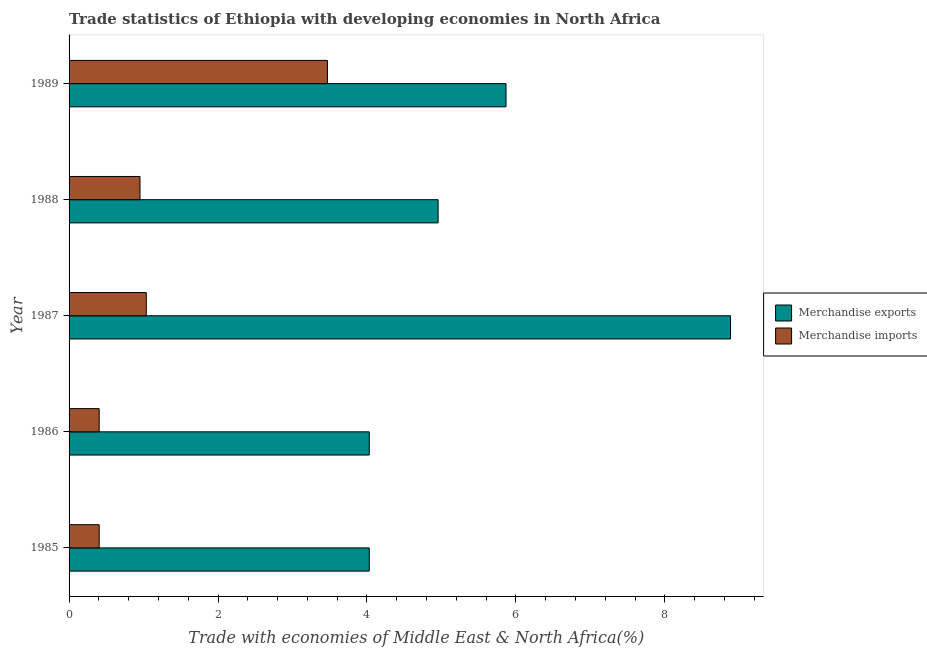How many different coloured bars are there?
Your response must be concise. 2. How many groups of bars are there?
Offer a very short reply. 5. Are the number of bars on each tick of the Y-axis equal?
Give a very brief answer. Yes. What is the label of the 5th group of bars from the top?
Your response must be concise. 1985. In how many cases, is the number of bars for a given year not equal to the number of legend labels?
Ensure brevity in your answer.  0. What is the merchandise exports in 1989?
Provide a succinct answer. 5.87. Across all years, what is the maximum merchandise imports?
Offer a terse response. 3.47. Across all years, what is the minimum merchandise exports?
Keep it short and to the point. 4.03. In which year was the merchandise imports maximum?
Your answer should be compact. 1989. What is the total merchandise imports in the graph?
Your answer should be compact. 6.27. What is the difference between the merchandise exports in 1985 and that in 1986?
Make the answer very short. -0. What is the difference between the merchandise imports in 1987 and the merchandise exports in 1988?
Your answer should be very brief. -3.92. What is the average merchandise imports per year?
Provide a short and direct response. 1.25. In the year 1985, what is the difference between the merchandise exports and merchandise imports?
Give a very brief answer. 3.63. What is the ratio of the merchandise imports in 1986 to that in 1988?
Ensure brevity in your answer.  0.42. Is the merchandise imports in 1986 less than that in 1987?
Give a very brief answer. Yes. Is the difference between the merchandise imports in 1986 and 1988 greater than the difference between the merchandise exports in 1986 and 1988?
Ensure brevity in your answer.  Yes. What is the difference between the highest and the second highest merchandise exports?
Offer a very short reply. 3.01. What is the difference between the highest and the lowest merchandise exports?
Make the answer very short. 4.85. In how many years, is the merchandise exports greater than the average merchandise exports taken over all years?
Ensure brevity in your answer.  2. What does the 2nd bar from the bottom in 1989 represents?
Provide a short and direct response. Merchandise imports. How many bars are there?
Keep it short and to the point. 10. Are all the bars in the graph horizontal?
Provide a succinct answer. Yes. How many years are there in the graph?
Keep it short and to the point. 5. Are the values on the major ticks of X-axis written in scientific E-notation?
Offer a terse response. No. How many legend labels are there?
Provide a succinct answer. 2. How are the legend labels stacked?
Give a very brief answer. Vertical. What is the title of the graph?
Offer a terse response. Trade statistics of Ethiopia with developing economies in North Africa. What is the label or title of the X-axis?
Provide a succinct answer. Trade with economies of Middle East & North Africa(%). What is the Trade with economies of Middle East & North Africa(%) of Merchandise exports in 1985?
Your answer should be compact. 4.03. What is the Trade with economies of Middle East & North Africa(%) of Merchandise imports in 1985?
Your response must be concise. 0.4. What is the Trade with economies of Middle East & North Africa(%) of Merchandise exports in 1986?
Your answer should be very brief. 4.03. What is the Trade with economies of Middle East & North Africa(%) of Merchandise imports in 1986?
Your response must be concise. 0.4. What is the Trade with economies of Middle East & North Africa(%) in Merchandise exports in 1987?
Your answer should be very brief. 8.88. What is the Trade with economies of Middle East & North Africa(%) in Merchandise imports in 1987?
Keep it short and to the point. 1.04. What is the Trade with economies of Middle East & North Africa(%) of Merchandise exports in 1988?
Provide a succinct answer. 4.96. What is the Trade with economies of Middle East & North Africa(%) of Merchandise imports in 1988?
Make the answer very short. 0.95. What is the Trade with economies of Middle East & North Africa(%) in Merchandise exports in 1989?
Keep it short and to the point. 5.87. What is the Trade with economies of Middle East & North Africa(%) in Merchandise imports in 1989?
Ensure brevity in your answer.  3.47. Across all years, what is the maximum Trade with economies of Middle East & North Africa(%) of Merchandise exports?
Your response must be concise. 8.88. Across all years, what is the maximum Trade with economies of Middle East & North Africa(%) in Merchandise imports?
Your response must be concise. 3.47. Across all years, what is the minimum Trade with economies of Middle East & North Africa(%) in Merchandise exports?
Give a very brief answer. 4.03. Across all years, what is the minimum Trade with economies of Middle East & North Africa(%) of Merchandise imports?
Give a very brief answer. 0.4. What is the total Trade with economies of Middle East & North Africa(%) in Merchandise exports in the graph?
Offer a very short reply. 27.77. What is the total Trade with economies of Middle East & North Africa(%) of Merchandise imports in the graph?
Your answer should be very brief. 6.27. What is the difference between the Trade with economies of Middle East & North Africa(%) of Merchandise exports in 1985 and that in 1986?
Give a very brief answer. -0. What is the difference between the Trade with economies of Middle East & North Africa(%) of Merchandise exports in 1985 and that in 1987?
Your answer should be compact. -4.85. What is the difference between the Trade with economies of Middle East & North Africa(%) in Merchandise imports in 1985 and that in 1987?
Offer a terse response. -0.63. What is the difference between the Trade with economies of Middle East & North Africa(%) in Merchandise exports in 1985 and that in 1988?
Offer a very short reply. -0.92. What is the difference between the Trade with economies of Middle East & North Africa(%) in Merchandise imports in 1985 and that in 1988?
Make the answer very short. -0.55. What is the difference between the Trade with economies of Middle East & North Africa(%) of Merchandise exports in 1985 and that in 1989?
Provide a succinct answer. -1.84. What is the difference between the Trade with economies of Middle East & North Africa(%) in Merchandise imports in 1985 and that in 1989?
Offer a very short reply. -3.06. What is the difference between the Trade with economies of Middle East & North Africa(%) in Merchandise exports in 1986 and that in 1987?
Give a very brief answer. -4.85. What is the difference between the Trade with economies of Middle East & North Africa(%) of Merchandise imports in 1986 and that in 1987?
Give a very brief answer. -0.63. What is the difference between the Trade with economies of Middle East & North Africa(%) in Merchandise exports in 1986 and that in 1988?
Your answer should be compact. -0.92. What is the difference between the Trade with economies of Middle East & North Africa(%) of Merchandise imports in 1986 and that in 1988?
Ensure brevity in your answer.  -0.55. What is the difference between the Trade with economies of Middle East & North Africa(%) of Merchandise exports in 1986 and that in 1989?
Your response must be concise. -1.84. What is the difference between the Trade with economies of Middle East & North Africa(%) of Merchandise imports in 1986 and that in 1989?
Keep it short and to the point. -3.06. What is the difference between the Trade with economies of Middle East & North Africa(%) in Merchandise exports in 1987 and that in 1988?
Ensure brevity in your answer.  3.93. What is the difference between the Trade with economies of Middle East & North Africa(%) of Merchandise imports in 1987 and that in 1988?
Your answer should be compact. 0.08. What is the difference between the Trade with economies of Middle East & North Africa(%) of Merchandise exports in 1987 and that in 1989?
Ensure brevity in your answer.  3.01. What is the difference between the Trade with economies of Middle East & North Africa(%) of Merchandise imports in 1987 and that in 1989?
Give a very brief answer. -2.43. What is the difference between the Trade with economies of Middle East & North Africa(%) of Merchandise exports in 1988 and that in 1989?
Your answer should be compact. -0.91. What is the difference between the Trade with economies of Middle East & North Africa(%) of Merchandise imports in 1988 and that in 1989?
Your response must be concise. -2.52. What is the difference between the Trade with economies of Middle East & North Africa(%) of Merchandise exports in 1985 and the Trade with economies of Middle East & North Africa(%) of Merchandise imports in 1986?
Make the answer very short. 3.63. What is the difference between the Trade with economies of Middle East & North Africa(%) of Merchandise exports in 1985 and the Trade with economies of Middle East & North Africa(%) of Merchandise imports in 1987?
Ensure brevity in your answer.  2.99. What is the difference between the Trade with economies of Middle East & North Africa(%) of Merchandise exports in 1985 and the Trade with economies of Middle East & North Africa(%) of Merchandise imports in 1988?
Offer a very short reply. 3.08. What is the difference between the Trade with economies of Middle East & North Africa(%) of Merchandise exports in 1985 and the Trade with economies of Middle East & North Africa(%) of Merchandise imports in 1989?
Your response must be concise. 0.56. What is the difference between the Trade with economies of Middle East & North Africa(%) in Merchandise exports in 1986 and the Trade with economies of Middle East & North Africa(%) in Merchandise imports in 1987?
Provide a succinct answer. 2.99. What is the difference between the Trade with economies of Middle East & North Africa(%) of Merchandise exports in 1986 and the Trade with economies of Middle East & North Africa(%) of Merchandise imports in 1988?
Give a very brief answer. 3.08. What is the difference between the Trade with economies of Middle East & North Africa(%) in Merchandise exports in 1986 and the Trade with economies of Middle East & North Africa(%) in Merchandise imports in 1989?
Keep it short and to the point. 0.56. What is the difference between the Trade with economies of Middle East & North Africa(%) in Merchandise exports in 1987 and the Trade with economies of Middle East & North Africa(%) in Merchandise imports in 1988?
Your answer should be compact. 7.93. What is the difference between the Trade with economies of Middle East & North Africa(%) in Merchandise exports in 1987 and the Trade with economies of Middle East & North Africa(%) in Merchandise imports in 1989?
Give a very brief answer. 5.41. What is the difference between the Trade with economies of Middle East & North Africa(%) in Merchandise exports in 1988 and the Trade with economies of Middle East & North Africa(%) in Merchandise imports in 1989?
Provide a short and direct response. 1.49. What is the average Trade with economies of Middle East & North Africa(%) in Merchandise exports per year?
Your answer should be very brief. 5.55. What is the average Trade with economies of Middle East & North Africa(%) in Merchandise imports per year?
Offer a very short reply. 1.25. In the year 1985, what is the difference between the Trade with economies of Middle East & North Africa(%) in Merchandise exports and Trade with economies of Middle East & North Africa(%) in Merchandise imports?
Your answer should be very brief. 3.63. In the year 1986, what is the difference between the Trade with economies of Middle East & North Africa(%) of Merchandise exports and Trade with economies of Middle East & North Africa(%) of Merchandise imports?
Give a very brief answer. 3.63. In the year 1987, what is the difference between the Trade with economies of Middle East & North Africa(%) in Merchandise exports and Trade with economies of Middle East & North Africa(%) in Merchandise imports?
Keep it short and to the point. 7.84. In the year 1988, what is the difference between the Trade with economies of Middle East & North Africa(%) in Merchandise exports and Trade with economies of Middle East & North Africa(%) in Merchandise imports?
Your answer should be very brief. 4. In the year 1989, what is the difference between the Trade with economies of Middle East & North Africa(%) of Merchandise exports and Trade with economies of Middle East & North Africa(%) of Merchandise imports?
Provide a short and direct response. 2.4. What is the ratio of the Trade with economies of Middle East & North Africa(%) in Merchandise exports in 1985 to that in 1986?
Your answer should be compact. 1. What is the ratio of the Trade with economies of Middle East & North Africa(%) in Merchandise exports in 1985 to that in 1987?
Ensure brevity in your answer.  0.45. What is the ratio of the Trade with economies of Middle East & North Africa(%) of Merchandise imports in 1985 to that in 1987?
Give a very brief answer. 0.39. What is the ratio of the Trade with economies of Middle East & North Africa(%) of Merchandise exports in 1985 to that in 1988?
Your response must be concise. 0.81. What is the ratio of the Trade with economies of Middle East & North Africa(%) in Merchandise imports in 1985 to that in 1988?
Your answer should be very brief. 0.42. What is the ratio of the Trade with economies of Middle East & North Africa(%) of Merchandise exports in 1985 to that in 1989?
Provide a short and direct response. 0.69. What is the ratio of the Trade with economies of Middle East & North Africa(%) of Merchandise imports in 1985 to that in 1989?
Your answer should be compact. 0.12. What is the ratio of the Trade with economies of Middle East & North Africa(%) of Merchandise exports in 1986 to that in 1987?
Keep it short and to the point. 0.45. What is the ratio of the Trade with economies of Middle East & North Africa(%) of Merchandise imports in 1986 to that in 1987?
Offer a terse response. 0.39. What is the ratio of the Trade with economies of Middle East & North Africa(%) of Merchandise exports in 1986 to that in 1988?
Offer a terse response. 0.81. What is the ratio of the Trade with economies of Middle East & North Africa(%) in Merchandise imports in 1986 to that in 1988?
Offer a terse response. 0.42. What is the ratio of the Trade with economies of Middle East & North Africa(%) in Merchandise exports in 1986 to that in 1989?
Your answer should be very brief. 0.69. What is the ratio of the Trade with economies of Middle East & North Africa(%) in Merchandise imports in 1986 to that in 1989?
Provide a short and direct response. 0.12. What is the ratio of the Trade with economies of Middle East & North Africa(%) in Merchandise exports in 1987 to that in 1988?
Provide a short and direct response. 1.79. What is the ratio of the Trade with economies of Middle East & North Africa(%) in Merchandise imports in 1987 to that in 1988?
Provide a succinct answer. 1.09. What is the ratio of the Trade with economies of Middle East & North Africa(%) in Merchandise exports in 1987 to that in 1989?
Your response must be concise. 1.51. What is the ratio of the Trade with economies of Middle East & North Africa(%) in Merchandise imports in 1987 to that in 1989?
Provide a succinct answer. 0.3. What is the ratio of the Trade with economies of Middle East & North Africa(%) in Merchandise exports in 1988 to that in 1989?
Offer a very short reply. 0.84. What is the ratio of the Trade with economies of Middle East & North Africa(%) of Merchandise imports in 1988 to that in 1989?
Your response must be concise. 0.27. What is the difference between the highest and the second highest Trade with economies of Middle East & North Africa(%) in Merchandise exports?
Offer a very short reply. 3.01. What is the difference between the highest and the second highest Trade with economies of Middle East & North Africa(%) in Merchandise imports?
Make the answer very short. 2.43. What is the difference between the highest and the lowest Trade with economies of Middle East & North Africa(%) in Merchandise exports?
Your answer should be compact. 4.85. What is the difference between the highest and the lowest Trade with economies of Middle East & North Africa(%) of Merchandise imports?
Offer a terse response. 3.06. 